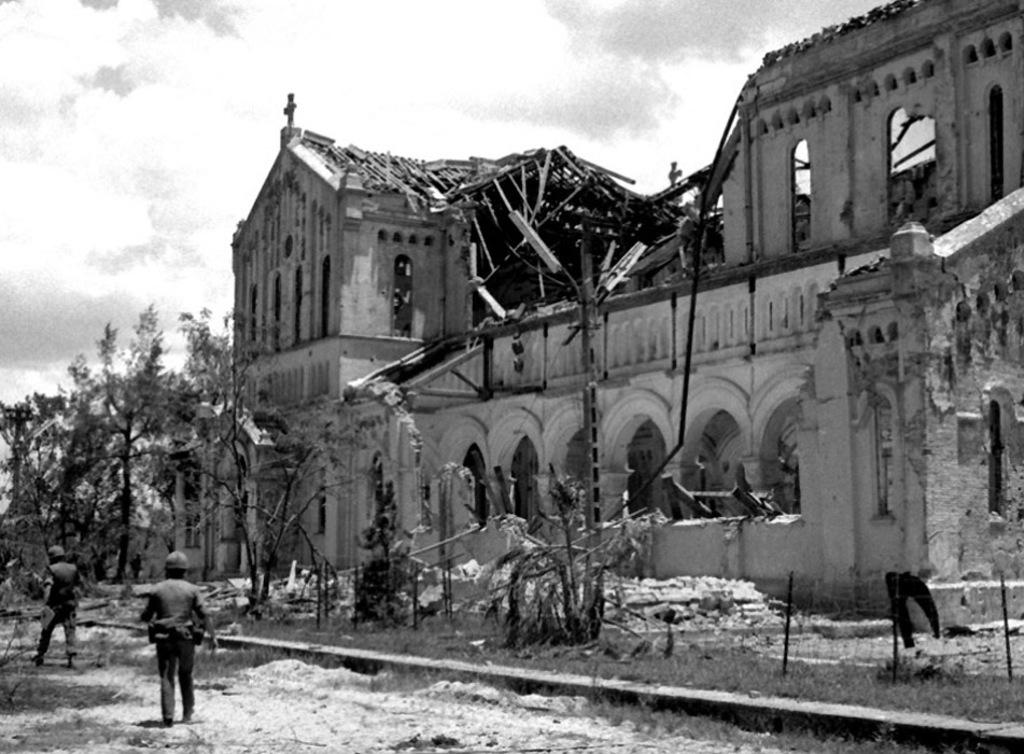How many people are present in the image? There are two people standing in the image. Where are the people standing? The people are standing on the ground. What type of natural environment is visible in the image? There are many trees visible in the image. What type of structure can be seen in the image? There is a building in the image. What is visible in the sky in the image? Clouds and the sky are visible in the image. Can you see a robin perched on the building in the image? There is no robin present in the image. Is there a cub playing among the trees in the image? There is no cub present in the image. 